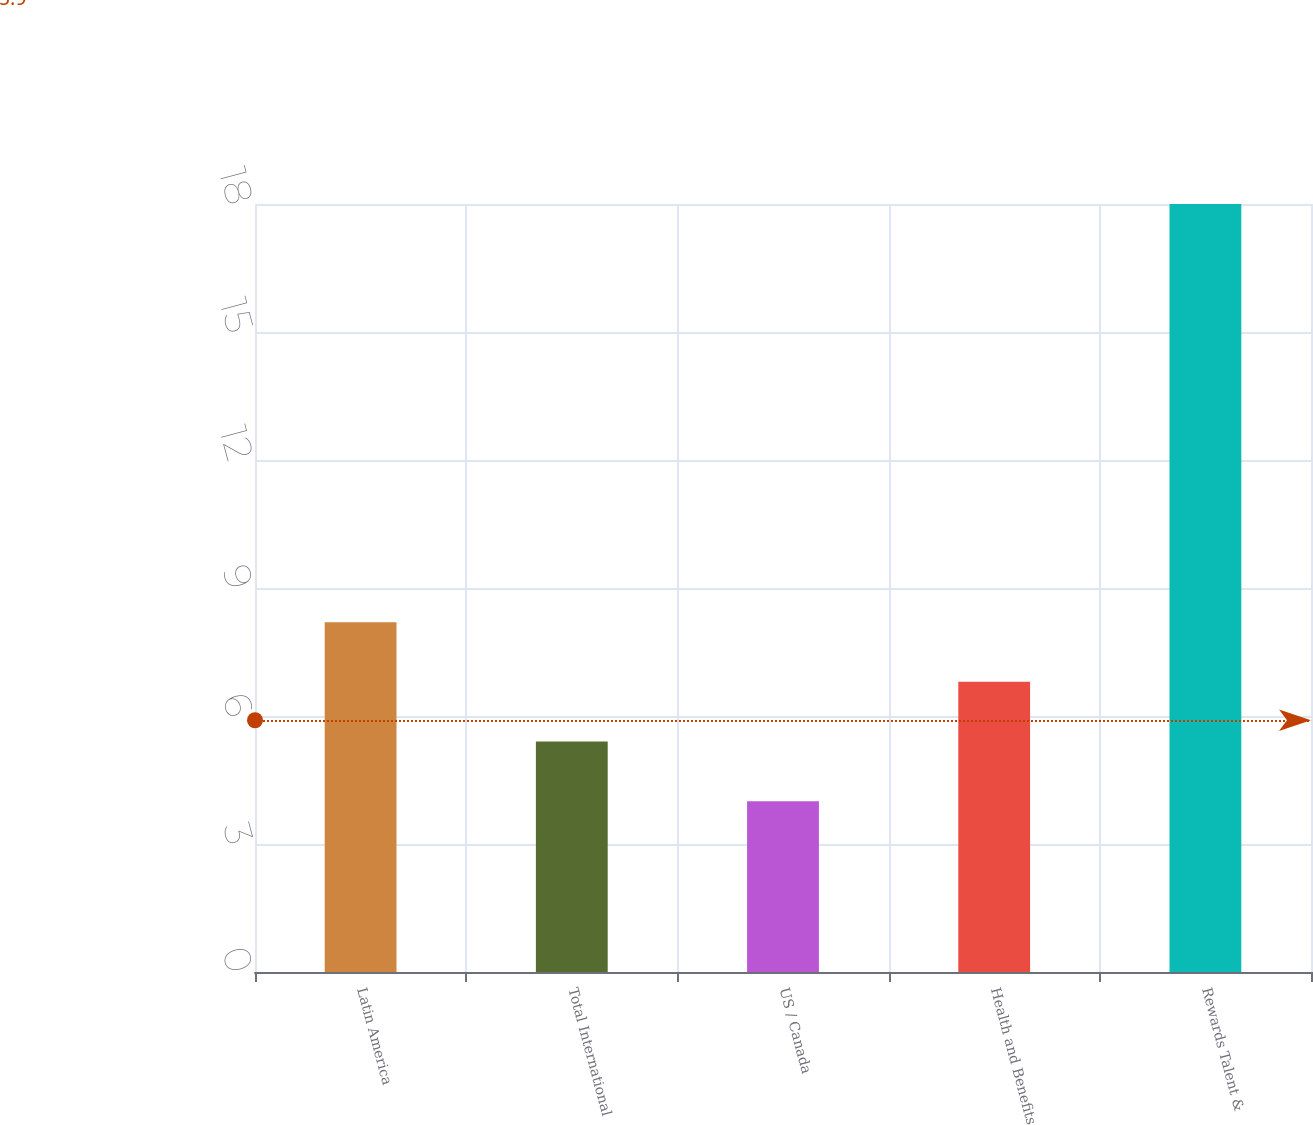Convert chart. <chart><loc_0><loc_0><loc_500><loc_500><bar_chart><fcel>Latin America<fcel>Total International<fcel>US / Canada<fcel>Health and Benefits<fcel>Rewards Talent &<nl><fcel>8.2<fcel>5.4<fcel>4<fcel>6.8<fcel>18<nl></chart> 